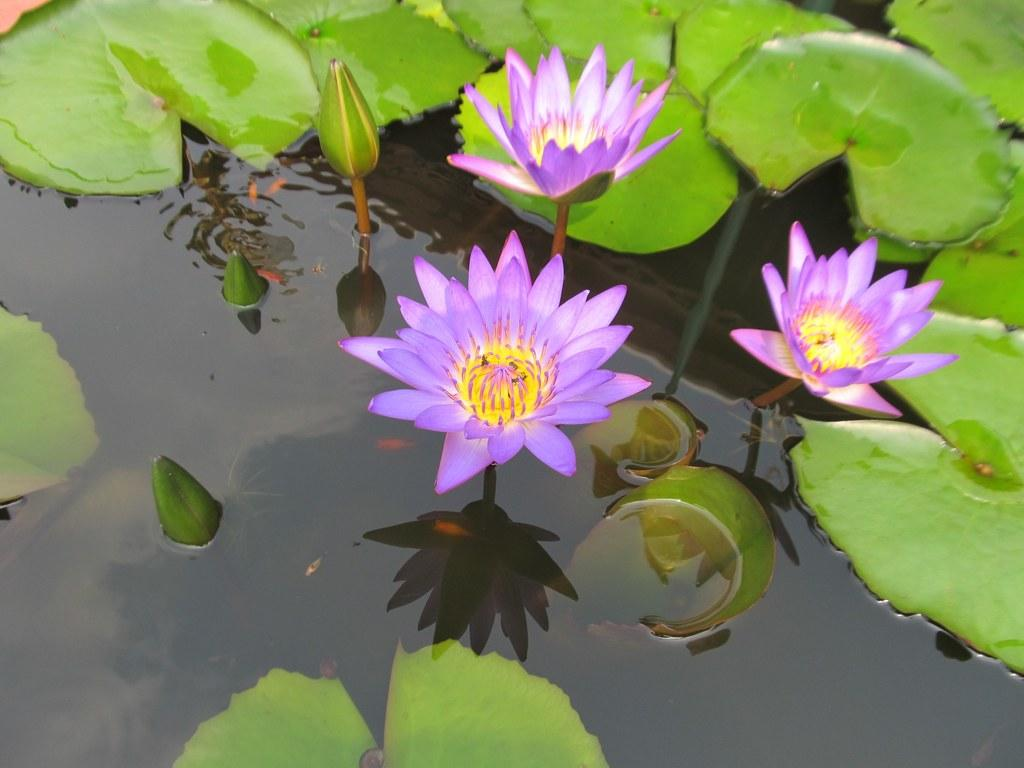What type of plants can be seen in the image? There are flowers in the image. What colors are the flowers? The flowers are in yellow and purple colors. Are there any other parts of the plants visible in the image? Yes, there are leaves in the image. What is the condition of the flowers and leaves in the image? The flowers and leaves are in water. What type of organization is responsible for the flowers in the image? There is no information about an organization being responsible for the flowers in the image. 